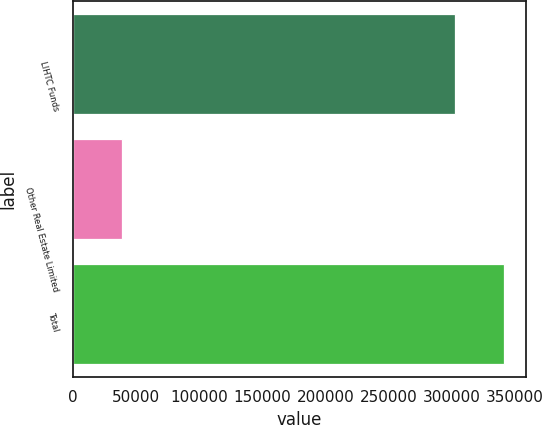<chart> <loc_0><loc_0><loc_500><loc_500><bar_chart><fcel>LIHTC Funds<fcel>Other Real Estate Limited<fcel>Total<nl><fcel>302749<fcel>38699<fcel>341448<nl></chart> 